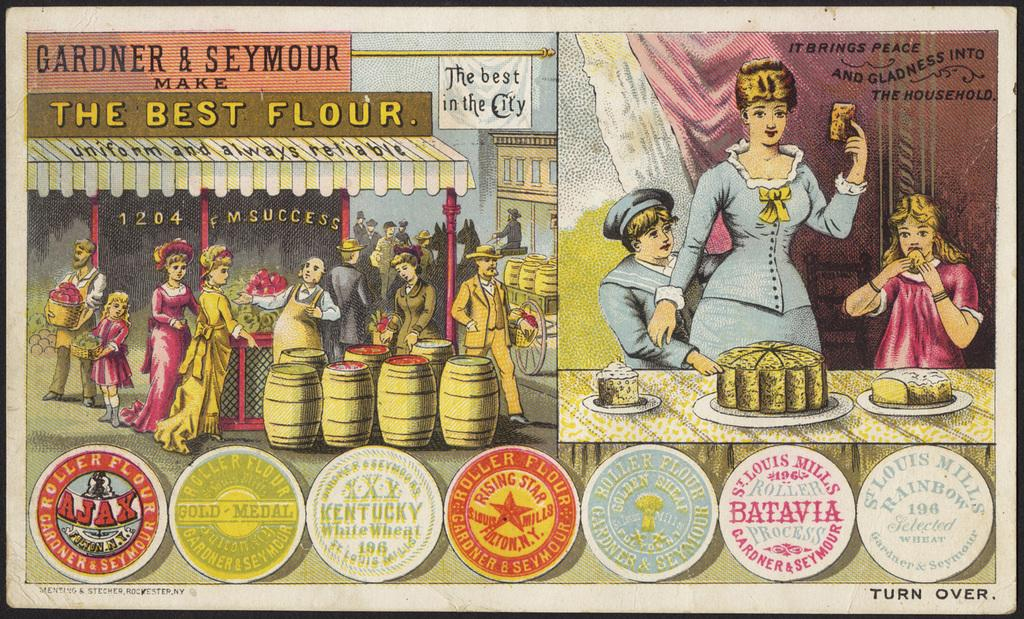<image>
Provide a brief description of the given image. A drawing which has the words 'The best flour' written in the top left. 